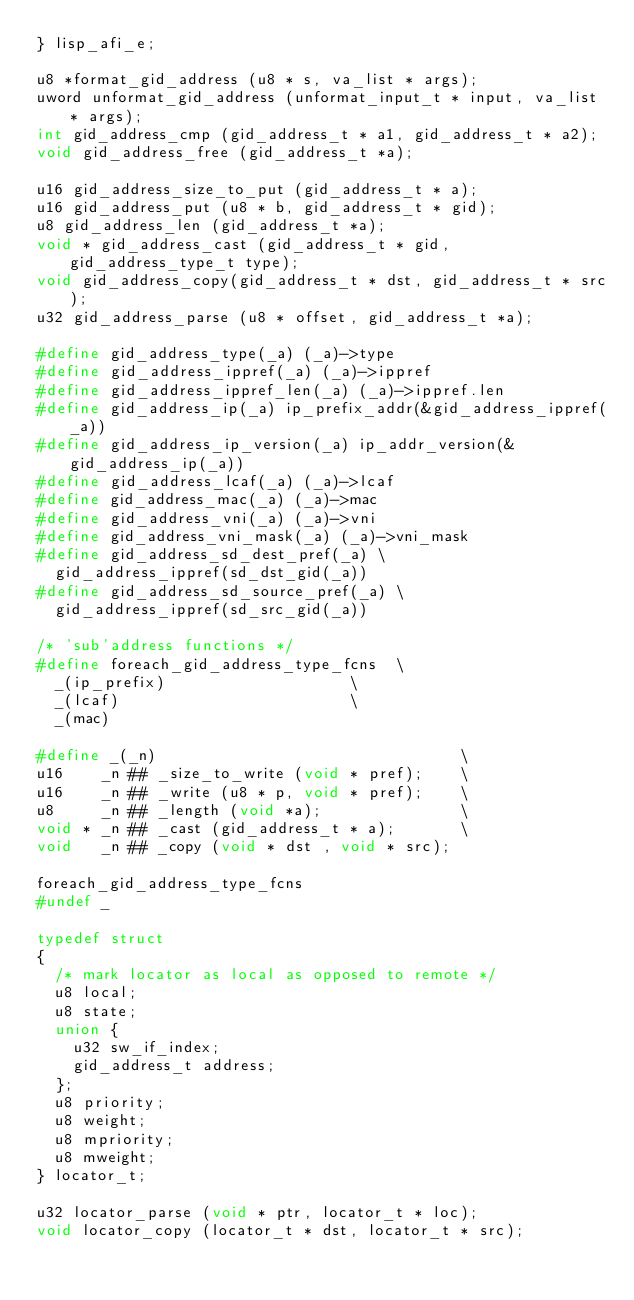Convert code to text. <code><loc_0><loc_0><loc_500><loc_500><_C_>} lisp_afi_e;

u8 *format_gid_address (u8 * s, va_list * args);
uword unformat_gid_address (unformat_input_t * input, va_list * args);
int gid_address_cmp (gid_address_t * a1, gid_address_t * a2);
void gid_address_free (gid_address_t *a);

u16 gid_address_size_to_put (gid_address_t * a);
u16 gid_address_put (u8 * b, gid_address_t * gid);
u8 gid_address_len (gid_address_t *a);
void * gid_address_cast (gid_address_t * gid, gid_address_type_t type);
void gid_address_copy(gid_address_t * dst, gid_address_t * src);
u32 gid_address_parse (u8 * offset, gid_address_t *a);

#define gid_address_type(_a) (_a)->type
#define gid_address_ippref(_a) (_a)->ippref
#define gid_address_ippref_len(_a) (_a)->ippref.len
#define gid_address_ip(_a) ip_prefix_addr(&gid_address_ippref(_a))
#define gid_address_ip_version(_a) ip_addr_version(&gid_address_ip(_a))
#define gid_address_lcaf(_a) (_a)->lcaf
#define gid_address_mac(_a) (_a)->mac
#define gid_address_vni(_a) (_a)->vni
#define gid_address_vni_mask(_a) (_a)->vni_mask
#define gid_address_sd_dest_pref(_a) \
  gid_address_ippref(sd_dst_gid(_a))
#define gid_address_sd_source_pref(_a) \
  gid_address_ippref(sd_src_gid(_a))

/* 'sub'address functions */
#define foreach_gid_address_type_fcns  \
  _(ip_prefix)                    \
  _(lcaf)                         \
  _(mac)

#define _(_n)                                 \
u16    _n ## _size_to_write (void * pref);    \
u16    _n ## _write (u8 * p, void * pref);    \
u8     _n ## _length (void *a);               \
void * _n ## _cast (gid_address_t * a);       \
void   _n ## _copy (void * dst , void * src);

foreach_gid_address_type_fcns
#undef _

typedef struct
{
  /* mark locator as local as opposed to remote */
  u8 local;
  u8 state;
  union {
    u32 sw_if_index;
    gid_address_t address;
  };
  u8 priority;
  u8 weight;
  u8 mpriority;
  u8 mweight;
} locator_t;

u32 locator_parse (void * ptr, locator_t * loc);
void locator_copy (locator_t * dst, locator_t * src);</code> 